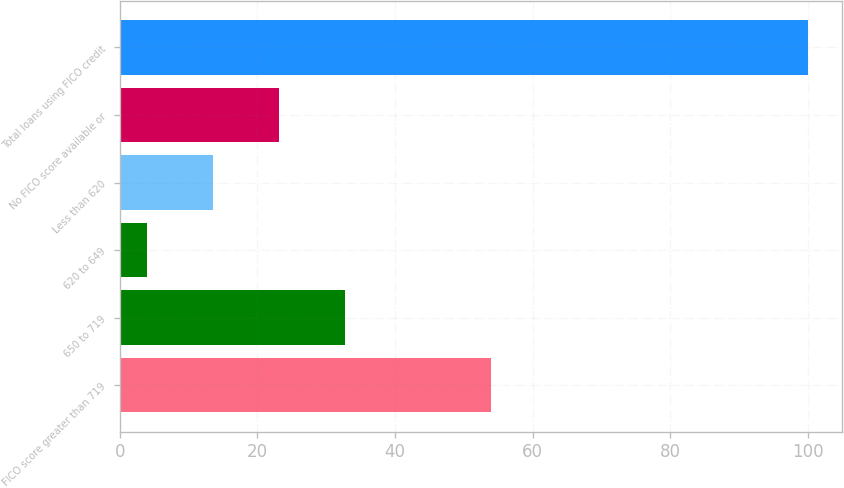Convert chart to OTSL. <chart><loc_0><loc_0><loc_500><loc_500><bar_chart><fcel>FICO score greater than 719<fcel>650 to 719<fcel>620 to 649<fcel>Less than 620<fcel>No FICO score available or<fcel>Total loans using FICO credit<nl><fcel>54<fcel>32.8<fcel>4<fcel>13.6<fcel>23.2<fcel>100<nl></chart> 